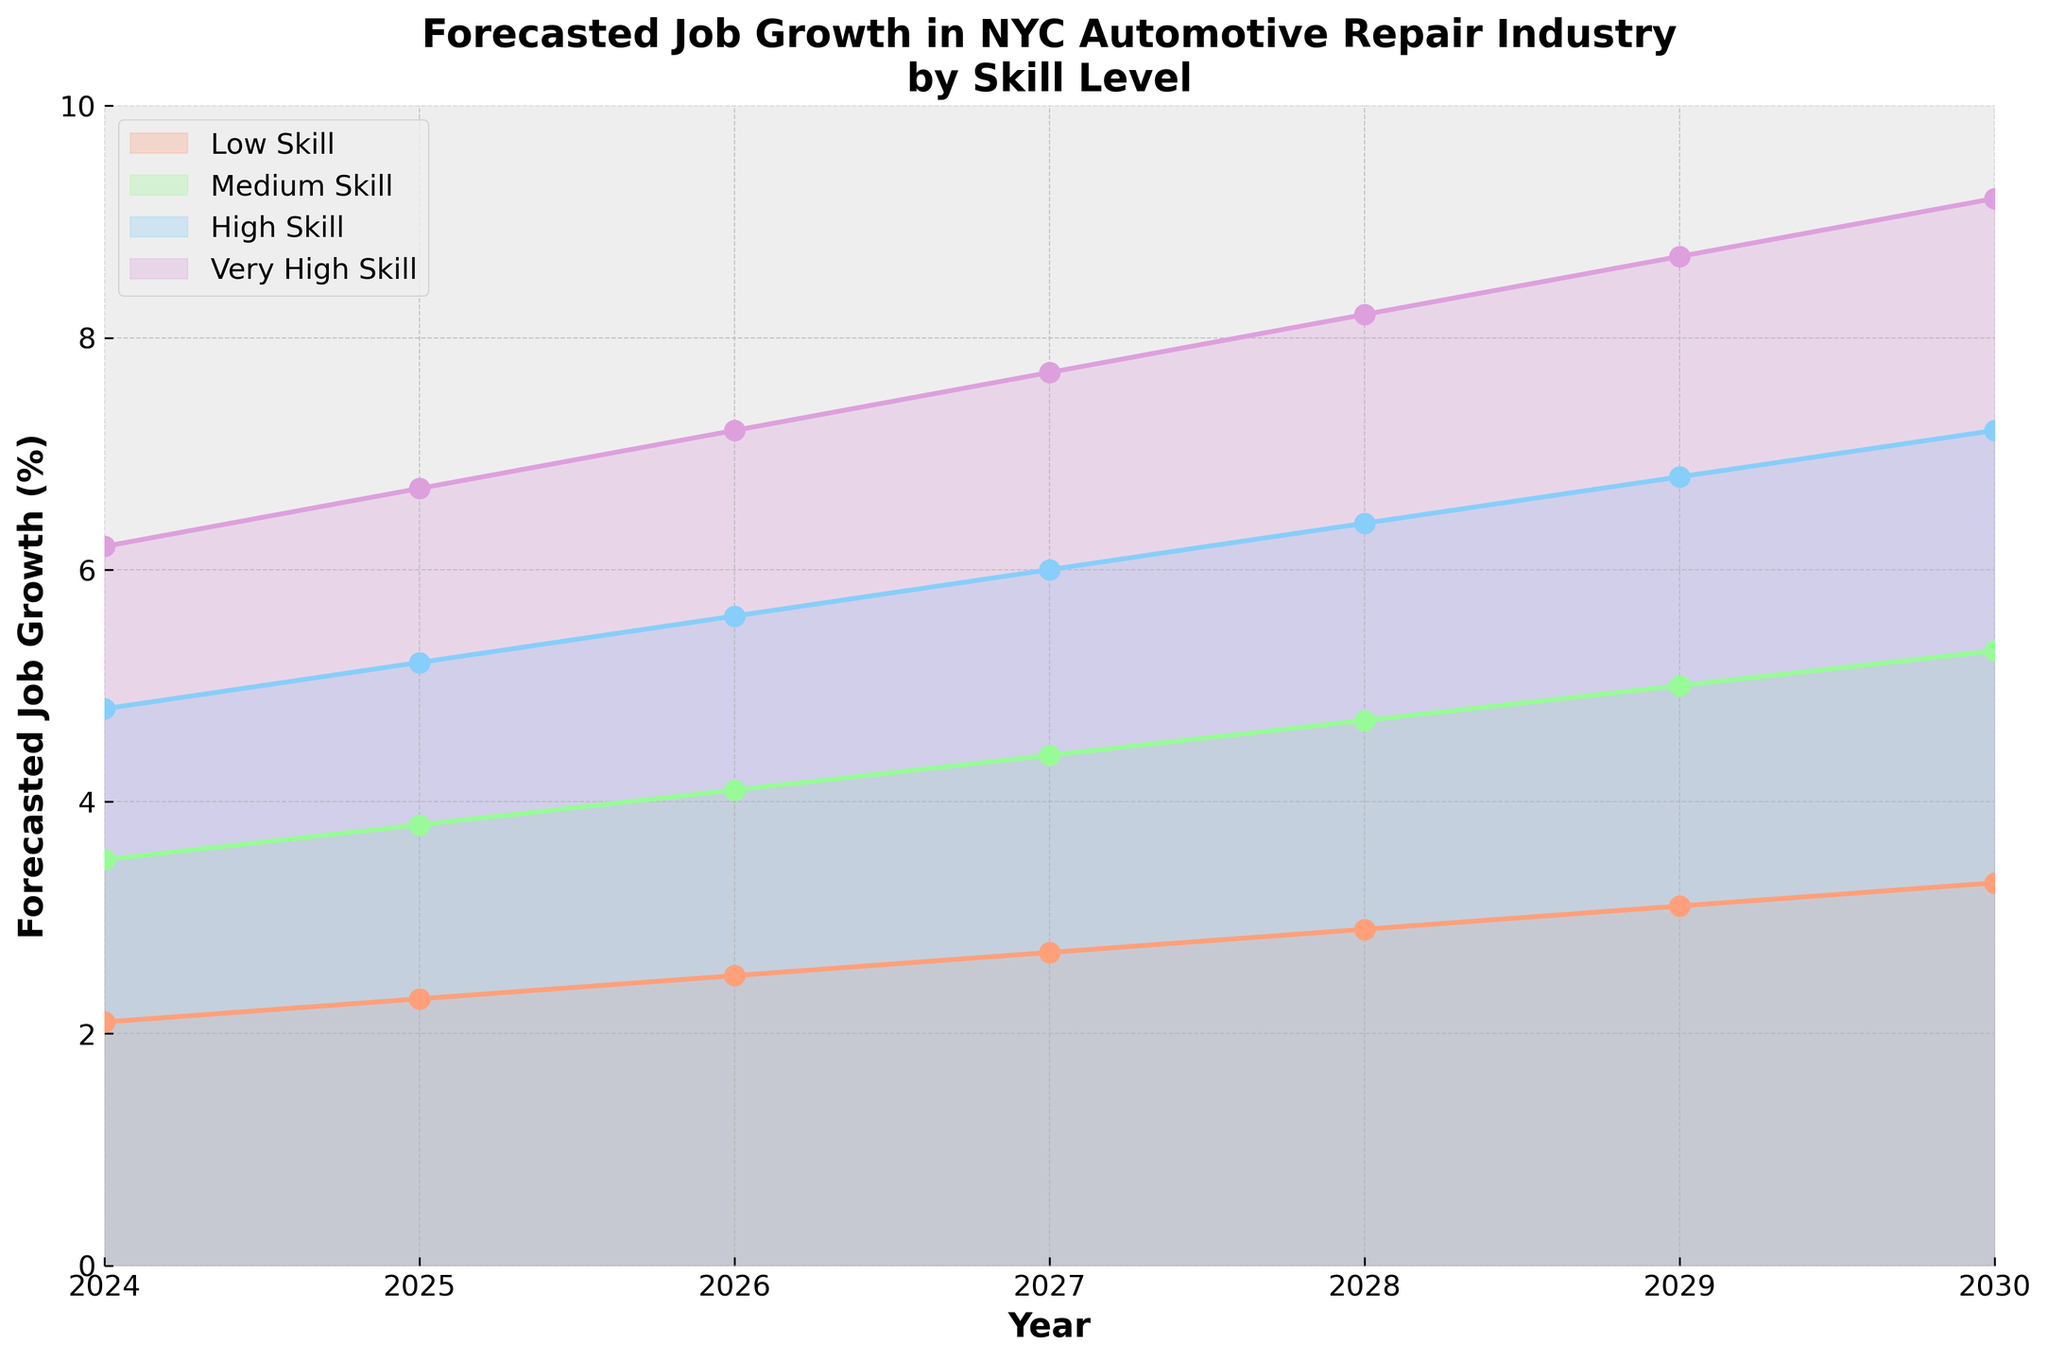What's the title of the figure? The title of the figure is displayed prominently at the top and summarizes the content of the chart. It says: "Forecasted Job Growth in NYC Automotive Repair Industry by Skill Level".
Answer: Forecasted Job Growth in NYC Automotive Repair Industry by Skill Level What are the four skill levels shown in the figure? The skill levels are displayed in the legend of the chart, represented by different color areas and lines. They are: Low Skill, Medium Skill, High Skill, and Very High Skill.
Answer: Low Skill, Medium Skill, High Skill, and Very High Skill In which year is the forecasted job growth for Medium Skill jobs above 5% for the first time? To find this, look at the Medium Skill line on the chart and see where it crosses the 5% mark on the y-axis. This happens in the year 2029.
Answer: 2029 What is the forecasted job growth for Low Skill jobs in 2027? Locate the year 2027 on the x-axis and follow it upward to where it intersects with the Low Skill line. The forecasted growth percentage at this intersection is 2.7%.
Answer: 2.7% By how much does the forecasted job growth for Very High Skill jobs increase from 2025 to 2028? Find the forecasted growth percentages for Very High Skill jobs in 2025 and 2028. The values are 6.7% and 8.2%, respectively. Subtract the 2025 value from the 2028 value: 8.2% - 6.7% = 1.5%.
Answer: 1.5% Which skill level is predicted to have the highest job growth in 2030? At the year 2030 on the x-axis, identify the highest line. The Very High Skill line is the highest, indicating the highest growth rate at 9.2%.
Answer: Very High Skill Compare the job growth forecast for High Skill and Medium Skill jobs in 2026. Which category has higher growth and by how much? The forecasted job growth for High Skill jobs in 2026 is 5.6%, and for Medium Skill jobs, it is 4.1%. Subtract the Medium Skill value from the High Skill value: 5.6% - 4.1% = 1.5%. Thus, High Skill has a higher growth rate by 1.5%.
Answer: High Skill by 1.5% What is the average forecasted job growth for Low Skill jobs from 2024 to 2030? To calculate the average, sum the forecasted values for Low Skill jobs from 2024 (2.1%), 2025 (2.3%), 2026 (2.5%), 2027 (2.7%), 2028 (2.9%), 2029 (3.1%), and 2030 (3.3%). The total sum is 2.1% + 2.3% + 2.5% + 2.7% + 2.9% + 3.1% + 3.3% = 18.9%. Divide by the number of years (7) to find the average: 18.9% / 7 ≈ 2.7%.
Answer: 2.7% By what percentage is Very High Skill job growth forecasted to increase from 2024 to 2030? Find the forecasted growth for Very High Skill jobs in 2024 (6.2%) and in 2030 (9.2%). Subtract the 2024 value from the 2030 value: 9.2% - 6.2% = 3%.
Answer: 3% What kind of trend is observable in the forecasted growth rates for all skill levels over the years? Observing the lines in the fan chart, all skill levels show an upward trend from 2024 to 2030, indicating increasing job growth over time.
Answer: Upward trend 